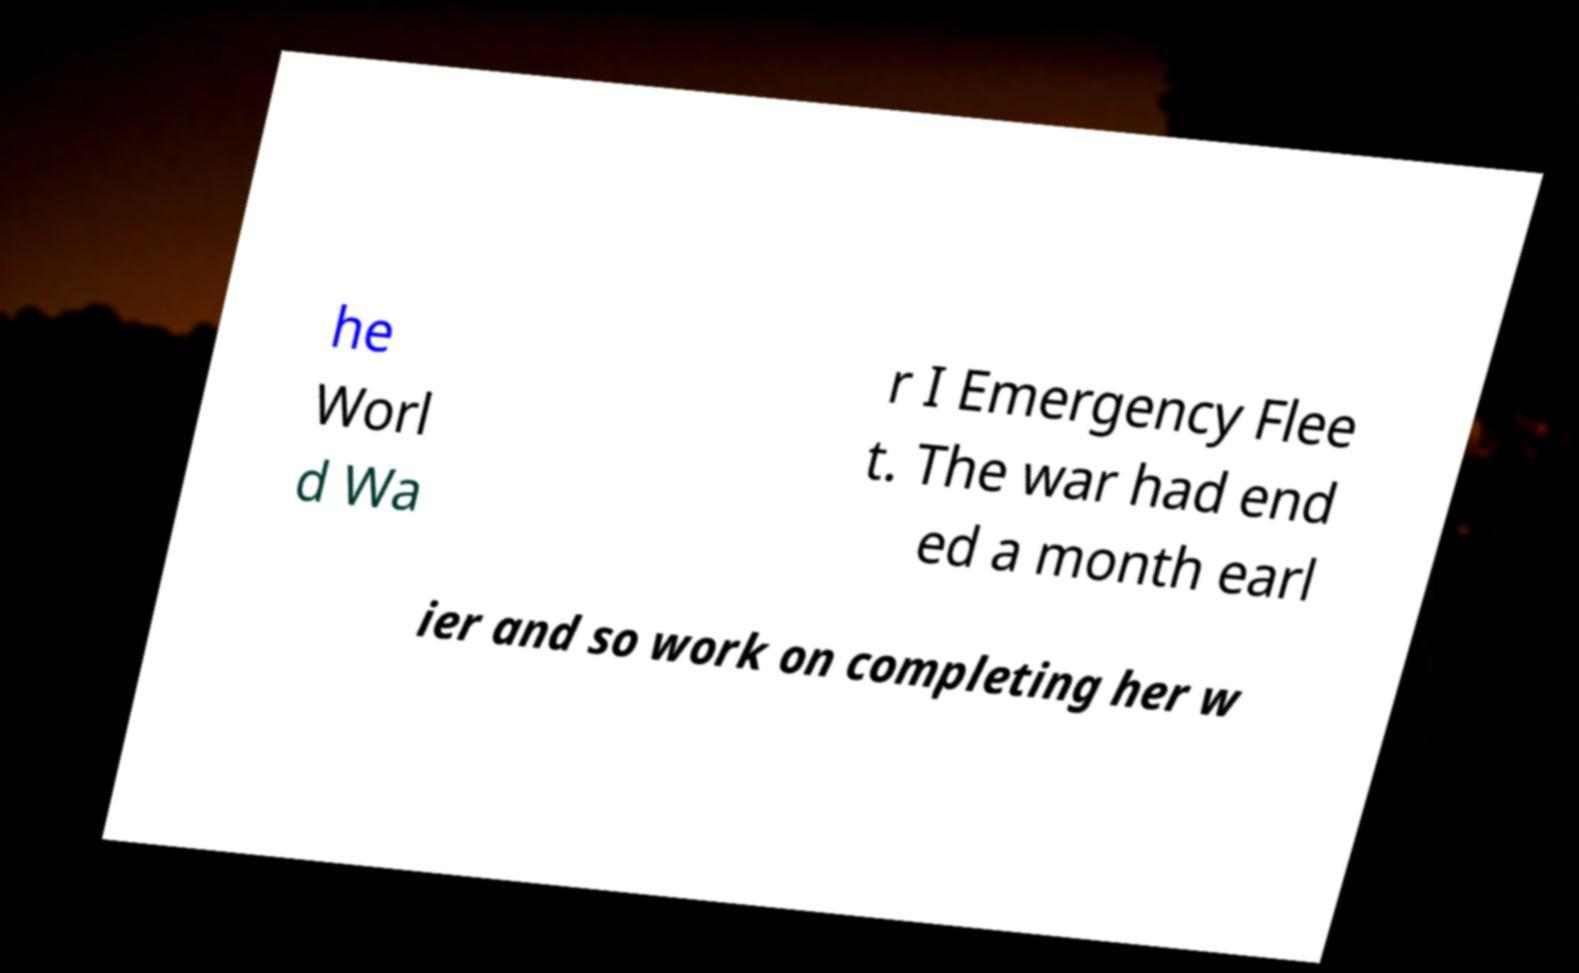There's text embedded in this image that I need extracted. Can you transcribe it verbatim? he Worl d Wa r I Emergency Flee t. The war had end ed a month earl ier and so work on completing her w 